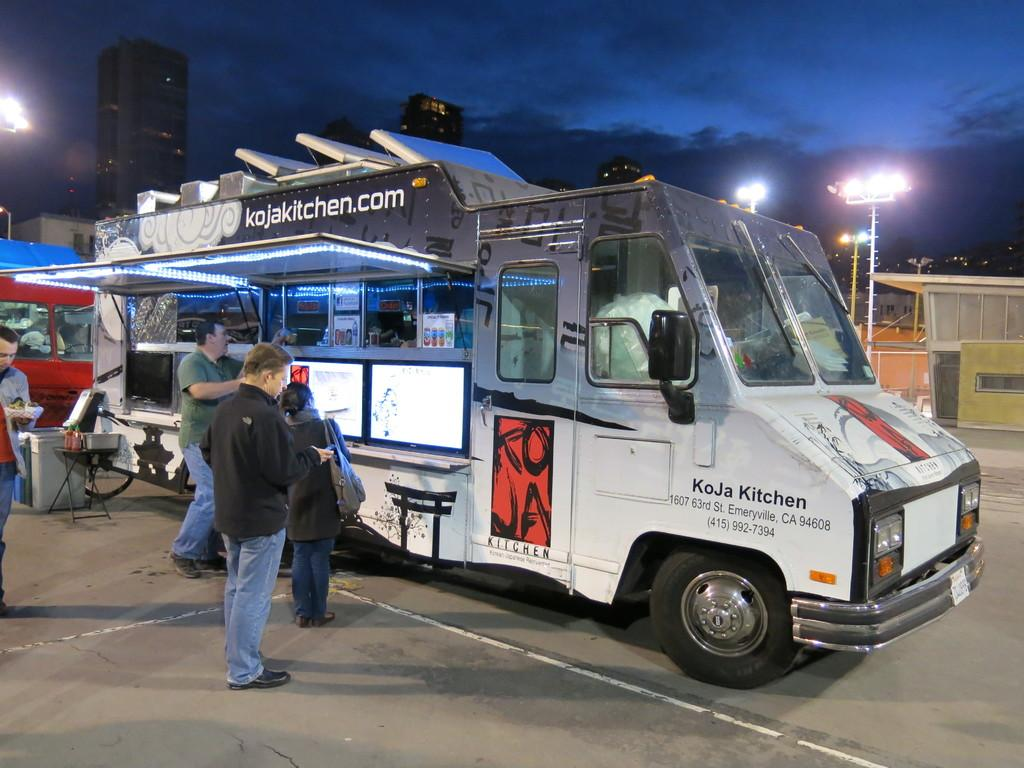<image>
Create a compact narrative representing the image presented. A busy lunch truck business that says kojakitchen.com. 